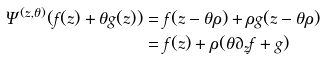<formula> <loc_0><loc_0><loc_500><loc_500>\Psi ^ { ( z , \theta ) } ( f ( z ) + \theta g ( z ) ) & = f ( z - \theta \rho ) + \rho g ( z - \theta \rho ) \\ & = f ( z ) + \rho ( \theta \partial _ { z } f + g )</formula> 